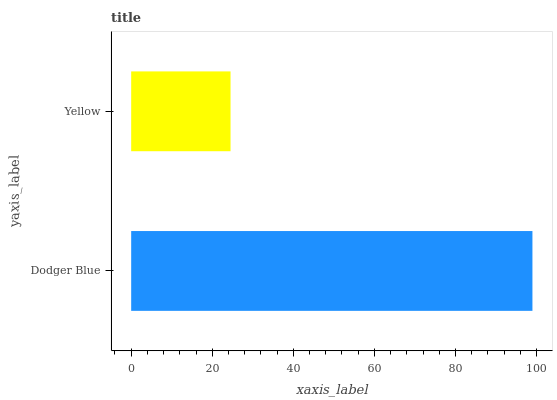Is Yellow the minimum?
Answer yes or no. Yes. Is Dodger Blue the maximum?
Answer yes or no. Yes. Is Yellow the maximum?
Answer yes or no. No. Is Dodger Blue greater than Yellow?
Answer yes or no. Yes. Is Yellow less than Dodger Blue?
Answer yes or no. Yes. Is Yellow greater than Dodger Blue?
Answer yes or no. No. Is Dodger Blue less than Yellow?
Answer yes or no. No. Is Dodger Blue the high median?
Answer yes or no. Yes. Is Yellow the low median?
Answer yes or no. Yes. Is Yellow the high median?
Answer yes or no. No. Is Dodger Blue the low median?
Answer yes or no. No. 